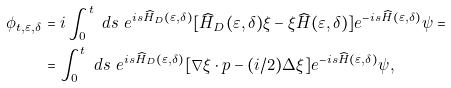<formula> <loc_0><loc_0><loc_500><loc_500>\phi _ { t , \varepsilon , \delta } & = i \int _ { 0 } ^ { t } \ d s \ e ^ { i s \widehat { H } _ { D } ( \varepsilon , \delta ) } [ \widehat { H } _ { D } ( \varepsilon , \delta ) \xi - \xi \widehat { H } ( \varepsilon , \delta ) ] e ^ { - i s \widehat { H } ( \varepsilon , \delta ) } \psi = \\ & = \int _ { 0 } ^ { t } \ d s \ e ^ { i s \widehat { H } _ { D } ( \varepsilon , \delta ) } [ \nabla \xi \cdot p - ( i / 2 ) \Delta \xi ] e ^ { - i s \widehat { H } ( \varepsilon , \delta ) } \psi ,</formula> 